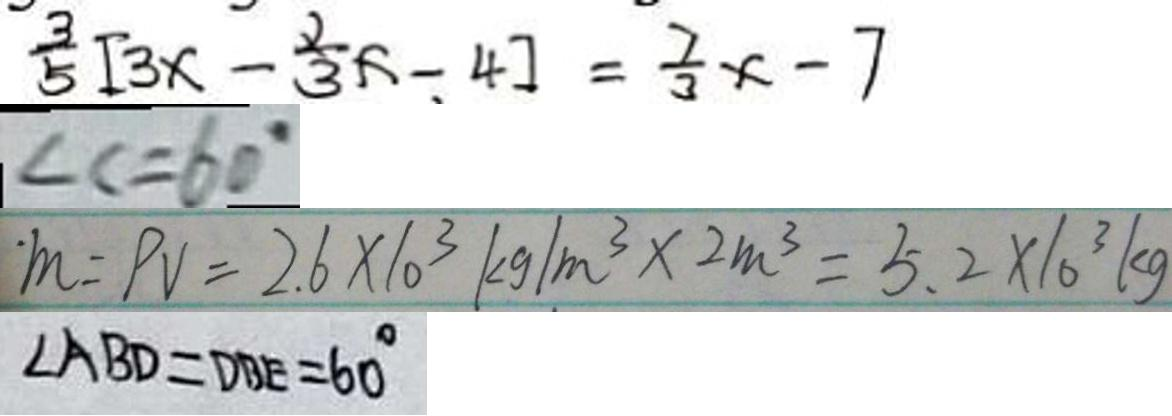<formula> <loc_0><loc_0><loc_500><loc_500>\frac { 3 } { 5 } [ 3 x - \frac { 2 } { 3 } x - 4 ] = \frac { 7 } { 3 } x - 7 
 \angle C = 6 0 ^ { \circ } 
 m = p v = 2 . 6 \times 1 0 ^ { 3 } k g / m ^ { 3 } \times 2 m ^ { 3 } = 5 . 2 \times 1 0 ^ { 3 } k g 
 \angle A B D = D B E = 6 0 ^ { \circ }</formula> 